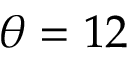Convert formula to latex. <formula><loc_0><loc_0><loc_500><loc_500>\theta = 1 2</formula> 